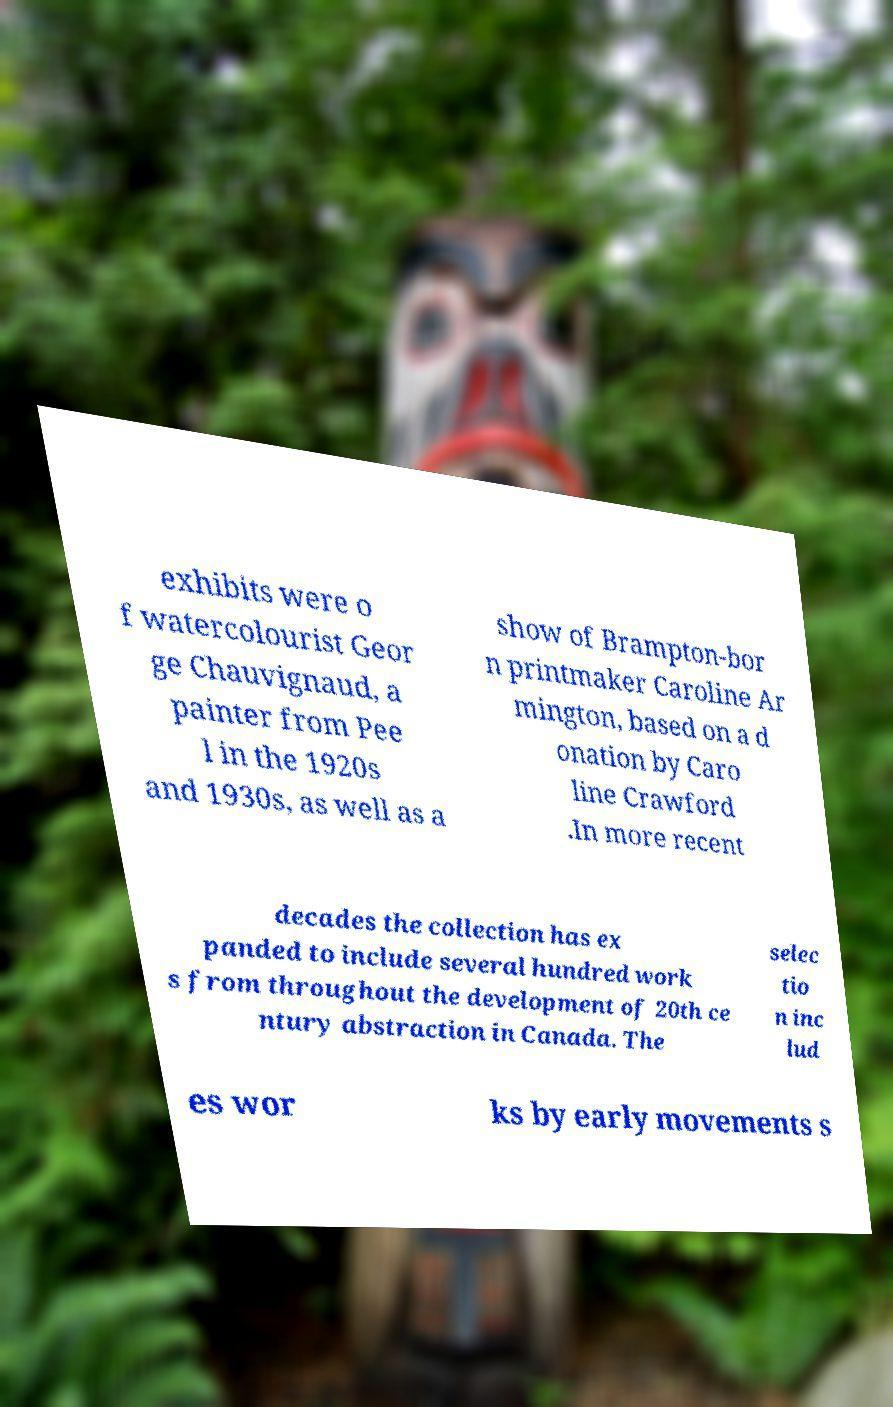Could you extract and type out the text from this image? exhibits were o f watercolourist Geor ge Chauvignaud, a painter from Pee l in the 1920s and 1930s, as well as a show of Brampton-bor n printmaker Caroline Ar mington, based on a d onation by Caro line Crawford .In more recent decades the collection has ex panded to include several hundred work s from throughout the development of 20th ce ntury abstraction in Canada. The selec tio n inc lud es wor ks by early movements s 